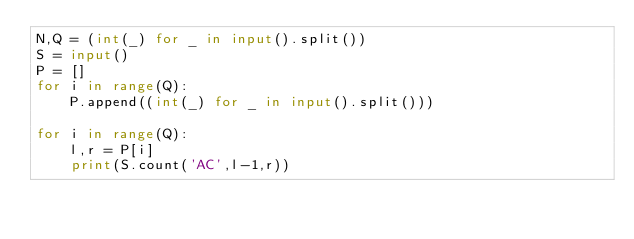<code> <loc_0><loc_0><loc_500><loc_500><_Python_>N,Q = (int(_) for _ in input().split())
S = input()
P = []
for i in range(Q):
    P.append((int(_) for _ in input().split()))

for i in range(Q):
    l,r = P[i]
    print(S.count('AC',l-1,r))
</code> 